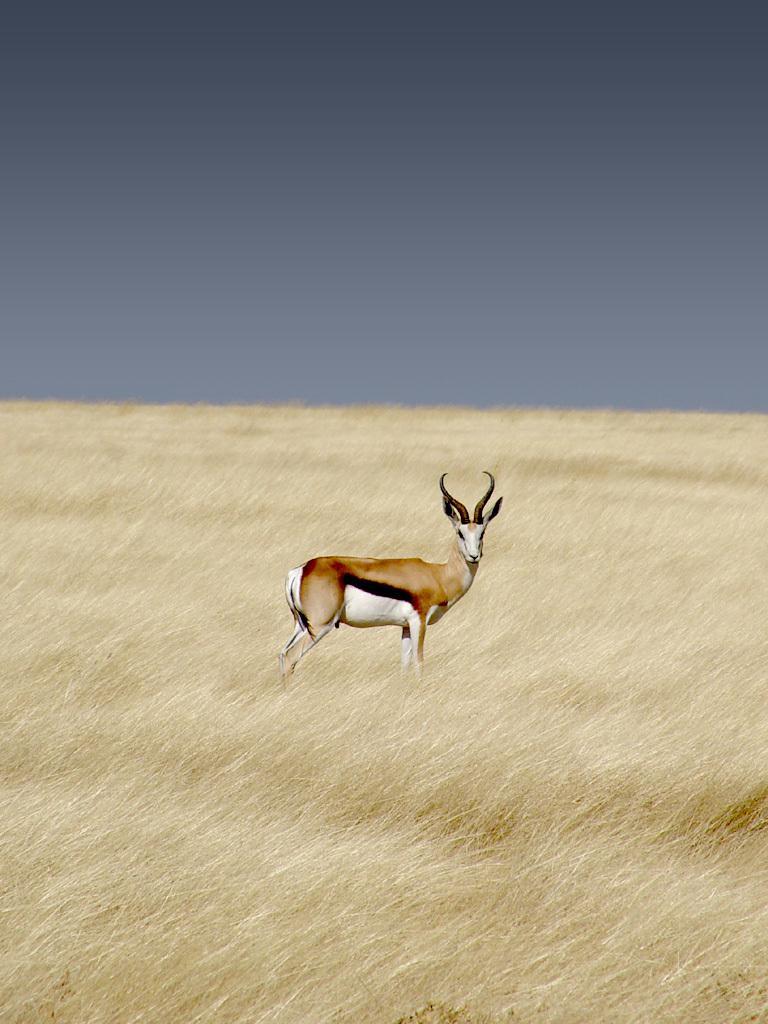In one or two sentences, can you explain what this image depicts? In the center of the image we can see an antelope. At the bottom there is grass. In the background there is sky. 